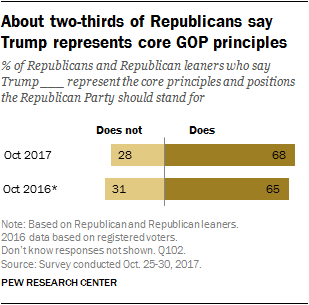Draw attention to some important aspects in this diagram. The average of the two longest bar values in the graph is 66.5. The first longest bar in the graph has a value of 68. 